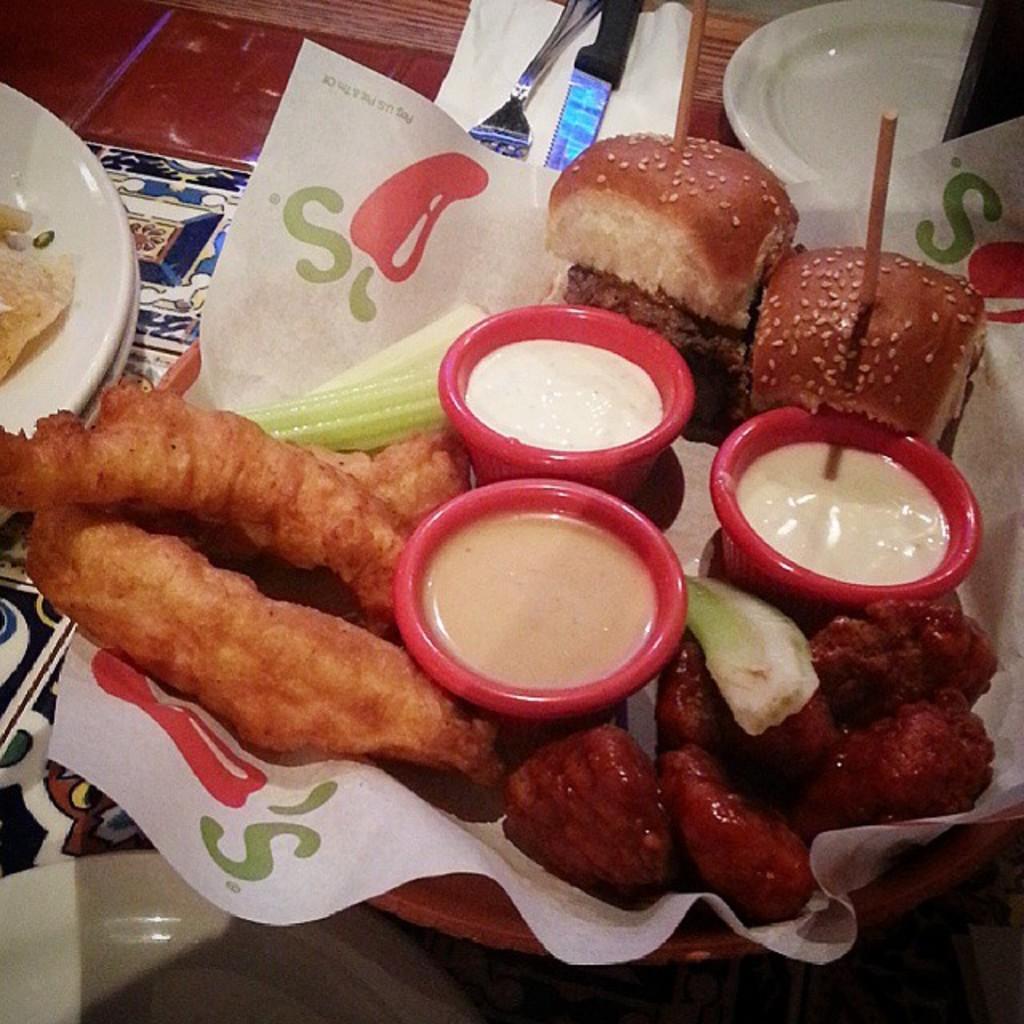Please provide a concise description of this image. In the center of the image there is a table. On the table we can see plates, fork, knife, tissue paper, cloth and a bowl which contains food items with paper, three cups. 